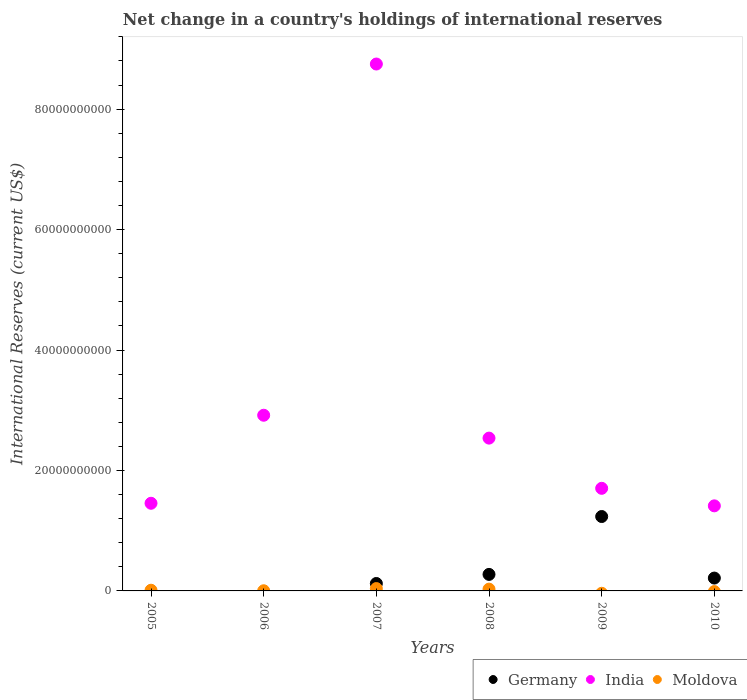What is the international reserves in India in 2010?
Give a very brief answer. 1.41e+1. Across all years, what is the maximum international reserves in India?
Provide a succinct answer. 8.75e+1. Across all years, what is the minimum international reserves in Moldova?
Keep it short and to the point. 0. In which year was the international reserves in India maximum?
Your response must be concise. 2007. What is the total international reserves in India in the graph?
Your response must be concise. 1.88e+11. What is the difference between the international reserves in Moldova in 2005 and that in 2008?
Ensure brevity in your answer.  -1.82e+08. What is the difference between the international reserves in Germany in 2006 and the international reserves in India in 2008?
Offer a very short reply. -2.54e+1. What is the average international reserves in Moldova per year?
Give a very brief answer. 1.38e+08. In the year 2007, what is the difference between the international reserves in India and international reserves in Moldova?
Give a very brief answer. 8.71e+1. What is the ratio of the international reserves in India in 2005 to that in 2006?
Keep it short and to the point. 0.5. Is the international reserves in Germany in 2007 less than that in 2010?
Offer a terse response. Yes. What is the difference between the highest and the second highest international reserves in India?
Offer a terse response. 5.83e+1. What is the difference between the highest and the lowest international reserves in Moldova?
Your answer should be compact. 3.90e+08. In how many years, is the international reserves in Moldova greater than the average international reserves in Moldova taken over all years?
Make the answer very short. 2. Is the sum of the international reserves in India in 2008 and 2010 greater than the maximum international reserves in Germany across all years?
Offer a terse response. Yes. Is the international reserves in Germany strictly less than the international reserves in Moldova over the years?
Your answer should be very brief. No. How many dotlines are there?
Your answer should be very brief. 3. How many legend labels are there?
Your answer should be very brief. 3. What is the title of the graph?
Your answer should be compact. Net change in a country's holdings of international reserves. Does "Myanmar" appear as one of the legend labels in the graph?
Give a very brief answer. No. What is the label or title of the Y-axis?
Keep it short and to the point. International Reserves (current US$). What is the International Reserves (current US$) in India in 2005?
Offer a very short reply. 1.46e+1. What is the International Reserves (current US$) in Moldova in 2005?
Keep it short and to the point. 1.14e+08. What is the International Reserves (current US$) of India in 2006?
Ensure brevity in your answer.  2.92e+1. What is the International Reserves (current US$) of Moldova in 2006?
Give a very brief answer. 2.75e+07. What is the International Reserves (current US$) of Germany in 2007?
Provide a short and direct response. 1.23e+09. What is the International Reserves (current US$) in India in 2007?
Offer a terse response. 8.75e+1. What is the International Reserves (current US$) of Moldova in 2007?
Provide a succinct answer. 3.90e+08. What is the International Reserves (current US$) in Germany in 2008?
Your response must be concise. 2.74e+09. What is the International Reserves (current US$) in India in 2008?
Give a very brief answer. 2.54e+1. What is the International Reserves (current US$) in Moldova in 2008?
Your response must be concise. 2.96e+08. What is the International Reserves (current US$) of Germany in 2009?
Your answer should be very brief. 1.24e+1. What is the International Reserves (current US$) of India in 2009?
Your answer should be compact. 1.70e+1. What is the International Reserves (current US$) of Germany in 2010?
Your response must be concise. 2.13e+09. What is the International Reserves (current US$) in India in 2010?
Your response must be concise. 1.41e+1. Across all years, what is the maximum International Reserves (current US$) in Germany?
Give a very brief answer. 1.24e+1. Across all years, what is the maximum International Reserves (current US$) of India?
Offer a very short reply. 8.75e+1. Across all years, what is the maximum International Reserves (current US$) of Moldova?
Provide a short and direct response. 3.90e+08. Across all years, what is the minimum International Reserves (current US$) in Germany?
Your answer should be very brief. 0. Across all years, what is the minimum International Reserves (current US$) in India?
Offer a very short reply. 1.41e+1. Across all years, what is the minimum International Reserves (current US$) in Moldova?
Your answer should be very brief. 0. What is the total International Reserves (current US$) in Germany in the graph?
Your response must be concise. 1.85e+1. What is the total International Reserves (current US$) of India in the graph?
Offer a terse response. 1.88e+11. What is the total International Reserves (current US$) of Moldova in the graph?
Ensure brevity in your answer.  8.28e+08. What is the difference between the International Reserves (current US$) of India in 2005 and that in 2006?
Provide a short and direct response. -1.46e+1. What is the difference between the International Reserves (current US$) of Moldova in 2005 and that in 2006?
Provide a short and direct response. 8.67e+07. What is the difference between the International Reserves (current US$) of India in 2005 and that in 2007?
Ensure brevity in your answer.  -7.29e+1. What is the difference between the International Reserves (current US$) of Moldova in 2005 and that in 2007?
Offer a very short reply. -2.76e+08. What is the difference between the International Reserves (current US$) in India in 2005 and that in 2008?
Offer a very short reply. -1.08e+1. What is the difference between the International Reserves (current US$) in Moldova in 2005 and that in 2008?
Your answer should be very brief. -1.82e+08. What is the difference between the International Reserves (current US$) of India in 2005 and that in 2009?
Your response must be concise. -2.48e+09. What is the difference between the International Reserves (current US$) in India in 2005 and that in 2010?
Keep it short and to the point. 4.27e+08. What is the difference between the International Reserves (current US$) in India in 2006 and that in 2007?
Your answer should be compact. -5.83e+1. What is the difference between the International Reserves (current US$) in Moldova in 2006 and that in 2007?
Your answer should be very brief. -3.62e+08. What is the difference between the International Reserves (current US$) of India in 2006 and that in 2008?
Provide a short and direct response. 3.80e+09. What is the difference between the International Reserves (current US$) of Moldova in 2006 and that in 2008?
Make the answer very short. -2.69e+08. What is the difference between the International Reserves (current US$) in India in 2006 and that in 2009?
Make the answer very short. 1.21e+1. What is the difference between the International Reserves (current US$) in India in 2006 and that in 2010?
Offer a terse response. 1.50e+1. What is the difference between the International Reserves (current US$) of Germany in 2007 and that in 2008?
Provide a short and direct response. -1.51e+09. What is the difference between the International Reserves (current US$) of India in 2007 and that in 2008?
Your response must be concise. 6.21e+1. What is the difference between the International Reserves (current US$) in Moldova in 2007 and that in 2008?
Your answer should be very brief. 9.37e+07. What is the difference between the International Reserves (current US$) in Germany in 2007 and that in 2009?
Offer a terse response. -1.11e+1. What is the difference between the International Reserves (current US$) of India in 2007 and that in 2009?
Offer a very short reply. 7.05e+1. What is the difference between the International Reserves (current US$) in Germany in 2007 and that in 2010?
Give a very brief answer. -9.00e+08. What is the difference between the International Reserves (current US$) in India in 2007 and that in 2010?
Make the answer very short. 7.34e+1. What is the difference between the International Reserves (current US$) of Germany in 2008 and that in 2009?
Your response must be concise. -9.61e+09. What is the difference between the International Reserves (current US$) of India in 2008 and that in 2009?
Your response must be concise. 8.34e+09. What is the difference between the International Reserves (current US$) of Germany in 2008 and that in 2010?
Offer a terse response. 6.09e+08. What is the difference between the International Reserves (current US$) in India in 2008 and that in 2010?
Keep it short and to the point. 1.12e+1. What is the difference between the International Reserves (current US$) of Germany in 2009 and that in 2010?
Your response must be concise. 1.02e+1. What is the difference between the International Reserves (current US$) in India in 2009 and that in 2010?
Your answer should be very brief. 2.91e+09. What is the difference between the International Reserves (current US$) of India in 2005 and the International Reserves (current US$) of Moldova in 2006?
Your answer should be very brief. 1.45e+1. What is the difference between the International Reserves (current US$) of India in 2005 and the International Reserves (current US$) of Moldova in 2007?
Ensure brevity in your answer.  1.42e+1. What is the difference between the International Reserves (current US$) in India in 2005 and the International Reserves (current US$) in Moldova in 2008?
Offer a very short reply. 1.43e+1. What is the difference between the International Reserves (current US$) in India in 2006 and the International Reserves (current US$) in Moldova in 2007?
Ensure brevity in your answer.  2.88e+1. What is the difference between the International Reserves (current US$) in India in 2006 and the International Reserves (current US$) in Moldova in 2008?
Your answer should be compact. 2.89e+1. What is the difference between the International Reserves (current US$) of Germany in 2007 and the International Reserves (current US$) of India in 2008?
Provide a short and direct response. -2.41e+1. What is the difference between the International Reserves (current US$) of Germany in 2007 and the International Reserves (current US$) of Moldova in 2008?
Ensure brevity in your answer.  9.38e+08. What is the difference between the International Reserves (current US$) of India in 2007 and the International Reserves (current US$) of Moldova in 2008?
Keep it short and to the point. 8.72e+1. What is the difference between the International Reserves (current US$) of Germany in 2007 and the International Reserves (current US$) of India in 2009?
Your response must be concise. -1.58e+1. What is the difference between the International Reserves (current US$) in Germany in 2007 and the International Reserves (current US$) in India in 2010?
Offer a terse response. -1.29e+1. What is the difference between the International Reserves (current US$) of Germany in 2008 and the International Reserves (current US$) of India in 2009?
Give a very brief answer. -1.43e+1. What is the difference between the International Reserves (current US$) of Germany in 2008 and the International Reserves (current US$) of India in 2010?
Give a very brief answer. -1.14e+1. What is the difference between the International Reserves (current US$) of Germany in 2009 and the International Reserves (current US$) of India in 2010?
Provide a short and direct response. -1.77e+09. What is the average International Reserves (current US$) in Germany per year?
Keep it short and to the point. 3.08e+09. What is the average International Reserves (current US$) of India per year?
Provide a short and direct response. 3.13e+1. What is the average International Reserves (current US$) of Moldova per year?
Provide a short and direct response. 1.38e+08. In the year 2005, what is the difference between the International Reserves (current US$) in India and International Reserves (current US$) in Moldova?
Your response must be concise. 1.44e+1. In the year 2006, what is the difference between the International Reserves (current US$) of India and International Reserves (current US$) of Moldova?
Your response must be concise. 2.91e+1. In the year 2007, what is the difference between the International Reserves (current US$) of Germany and International Reserves (current US$) of India?
Provide a short and direct response. -8.63e+1. In the year 2007, what is the difference between the International Reserves (current US$) in Germany and International Reserves (current US$) in Moldova?
Ensure brevity in your answer.  8.44e+08. In the year 2007, what is the difference between the International Reserves (current US$) of India and International Reserves (current US$) of Moldova?
Provide a succinct answer. 8.71e+1. In the year 2008, what is the difference between the International Reserves (current US$) of Germany and International Reserves (current US$) of India?
Your response must be concise. -2.26e+1. In the year 2008, what is the difference between the International Reserves (current US$) in Germany and International Reserves (current US$) in Moldova?
Your response must be concise. 2.45e+09. In the year 2008, what is the difference between the International Reserves (current US$) in India and International Reserves (current US$) in Moldova?
Offer a very short reply. 2.51e+1. In the year 2009, what is the difference between the International Reserves (current US$) in Germany and International Reserves (current US$) in India?
Your answer should be very brief. -4.68e+09. In the year 2010, what is the difference between the International Reserves (current US$) of Germany and International Reserves (current US$) of India?
Ensure brevity in your answer.  -1.20e+1. What is the ratio of the International Reserves (current US$) in India in 2005 to that in 2006?
Your answer should be compact. 0.5. What is the ratio of the International Reserves (current US$) in Moldova in 2005 to that in 2006?
Provide a short and direct response. 4.16. What is the ratio of the International Reserves (current US$) in India in 2005 to that in 2007?
Make the answer very short. 0.17. What is the ratio of the International Reserves (current US$) in Moldova in 2005 to that in 2007?
Your answer should be compact. 0.29. What is the ratio of the International Reserves (current US$) of India in 2005 to that in 2008?
Give a very brief answer. 0.57. What is the ratio of the International Reserves (current US$) in Moldova in 2005 to that in 2008?
Make the answer very short. 0.39. What is the ratio of the International Reserves (current US$) of India in 2005 to that in 2009?
Your response must be concise. 0.85. What is the ratio of the International Reserves (current US$) of India in 2005 to that in 2010?
Ensure brevity in your answer.  1.03. What is the ratio of the International Reserves (current US$) in India in 2006 to that in 2007?
Your answer should be very brief. 0.33. What is the ratio of the International Reserves (current US$) in Moldova in 2006 to that in 2007?
Make the answer very short. 0.07. What is the ratio of the International Reserves (current US$) in India in 2006 to that in 2008?
Make the answer very short. 1.15. What is the ratio of the International Reserves (current US$) of Moldova in 2006 to that in 2008?
Your answer should be very brief. 0.09. What is the ratio of the International Reserves (current US$) in India in 2006 to that in 2009?
Offer a very short reply. 1.71. What is the ratio of the International Reserves (current US$) in India in 2006 to that in 2010?
Your answer should be very brief. 2.06. What is the ratio of the International Reserves (current US$) of Germany in 2007 to that in 2008?
Offer a terse response. 0.45. What is the ratio of the International Reserves (current US$) of India in 2007 to that in 2008?
Offer a very short reply. 3.45. What is the ratio of the International Reserves (current US$) in Moldova in 2007 to that in 2008?
Your answer should be very brief. 1.32. What is the ratio of the International Reserves (current US$) in Germany in 2007 to that in 2009?
Ensure brevity in your answer.  0.1. What is the ratio of the International Reserves (current US$) in India in 2007 to that in 2009?
Provide a succinct answer. 5.14. What is the ratio of the International Reserves (current US$) in Germany in 2007 to that in 2010?
Give a very brief answer. 0.58. What is the ratio of the International Reserves (current US$) in India in 2007 to that in 2010?
Keep it short and to the point. 6.19. What is the ratio of the International Reserves (current US$) of Germany in 2008 to that in 2009?
Give a very brief answer. 0.22. What is the ratio of the International Reserves (current US$) in India in 2008 to that in 2009?
Give a very brief answer. 1.49. What is the ratio of the International Reserves (current US$) of Germany in 2008 to that in 2010?
Offer a very short reply. 1.29. What is the ratio of the International Reserves (current US$) in India in 2008 to that in 2010?
Offer a very short reply. 1.8. What is the ratio of the International Reserves (current US$) of Germany in 2009 to that in 2010?
Offer a terse response. 5.79. What is the ratio of the International Reserves (current US$) of India in 2009 to that in 2010?
Keep it short and to the point. 1.21. What is the difference between the highest and the second highest International Reserves (current US$) in Germany?
Your response must be concise. 9.61e+09. What is the difference between the highest and the second highest International Reserves (current US$) in India?
Provide a succinct answer. 5.83e+1. What is the difference between the highest and the second highest International Reserves (current US$) of Moldova?
Provide a short and direct response. 9.37e+07. What is the difference between the highest and the lowest International Reserves (current US$) of Germany?
Offer a terse response. 1.24e+1. What is the difference between the highest and the lowest International Reserves (current US$) in India?
Make the answer very short. 7.34e+1. What is the difference between the highest and the lowest International Reserves (current US$) in Moldova?
Give a very brief answer. 3.90e+08. 